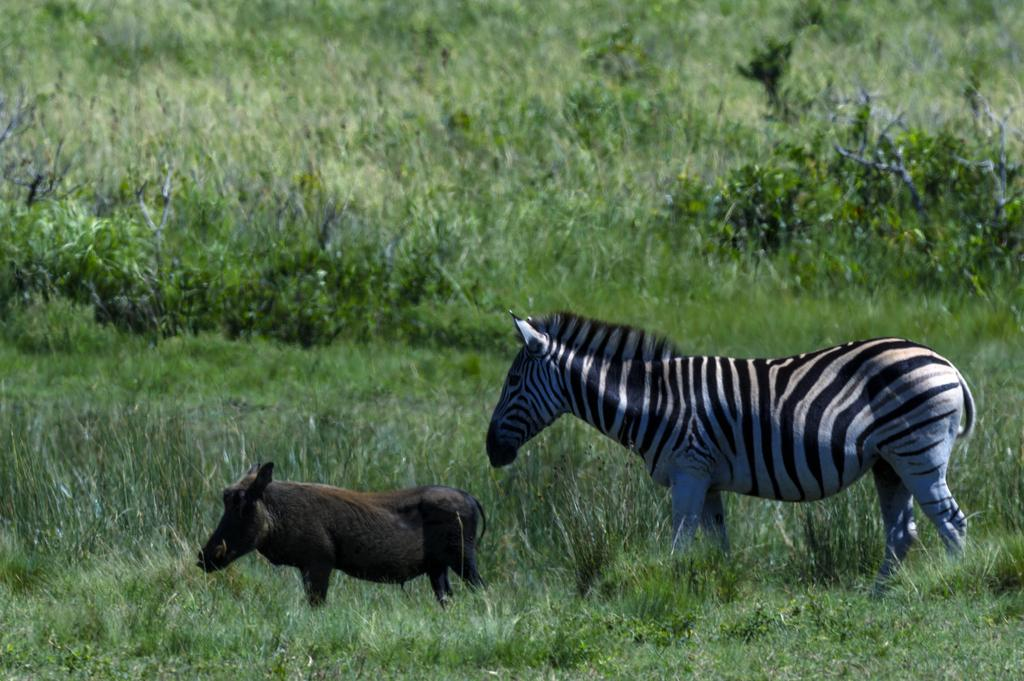What type of animal can be seen in the image? There is a giraffe and a wild boar in the image. Where are the animals located in the image? Both animals are on the surface of the grass. What color is the bead that the giraffe is holding in the image? There is no bead present in the image, and the giraffe is not holding anything. 